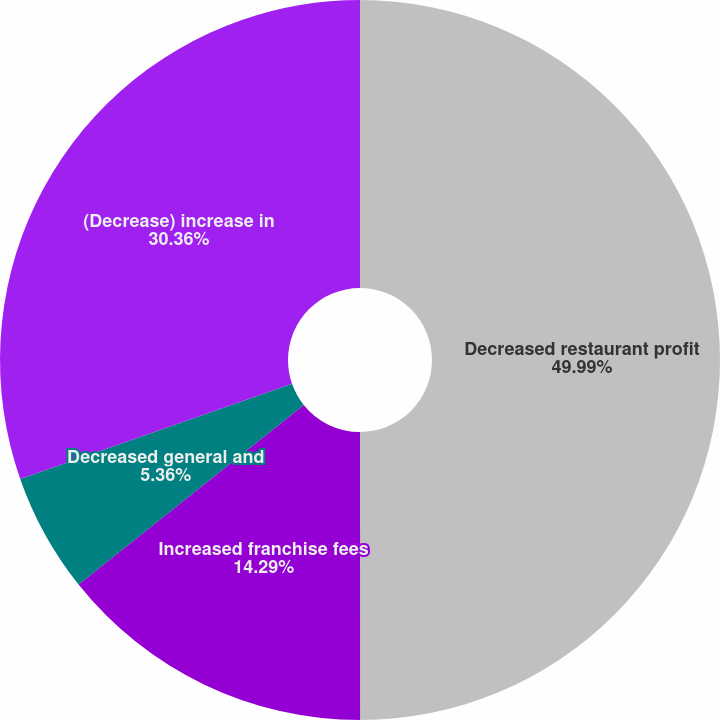Convert chart to OTSL. <chart><loc_0><loc_0><loc_500><loc_500><pie_chart><fcel>Decreased restaurant profit<fcel>Increased franchise fees<fcel>Decreased general and<fcel>(Decrease) increase in<nl><fcel>50.0%<fcel>14.29%<fcel>5.36%<fcel>30.36%<nl></chart> 